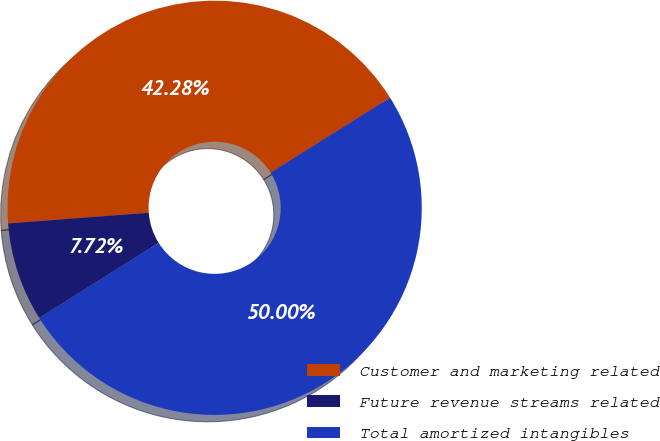<chart> <loc_0><loc_0><loc_500><loc_500><pie_chart><fcel>Customer and marketing related<fcel>Future revenue streams related<fcel>Total amortized intangibles<nl><fcel>42.28%<fcel>7.72%<fcel>50.0%<nl></chart> 